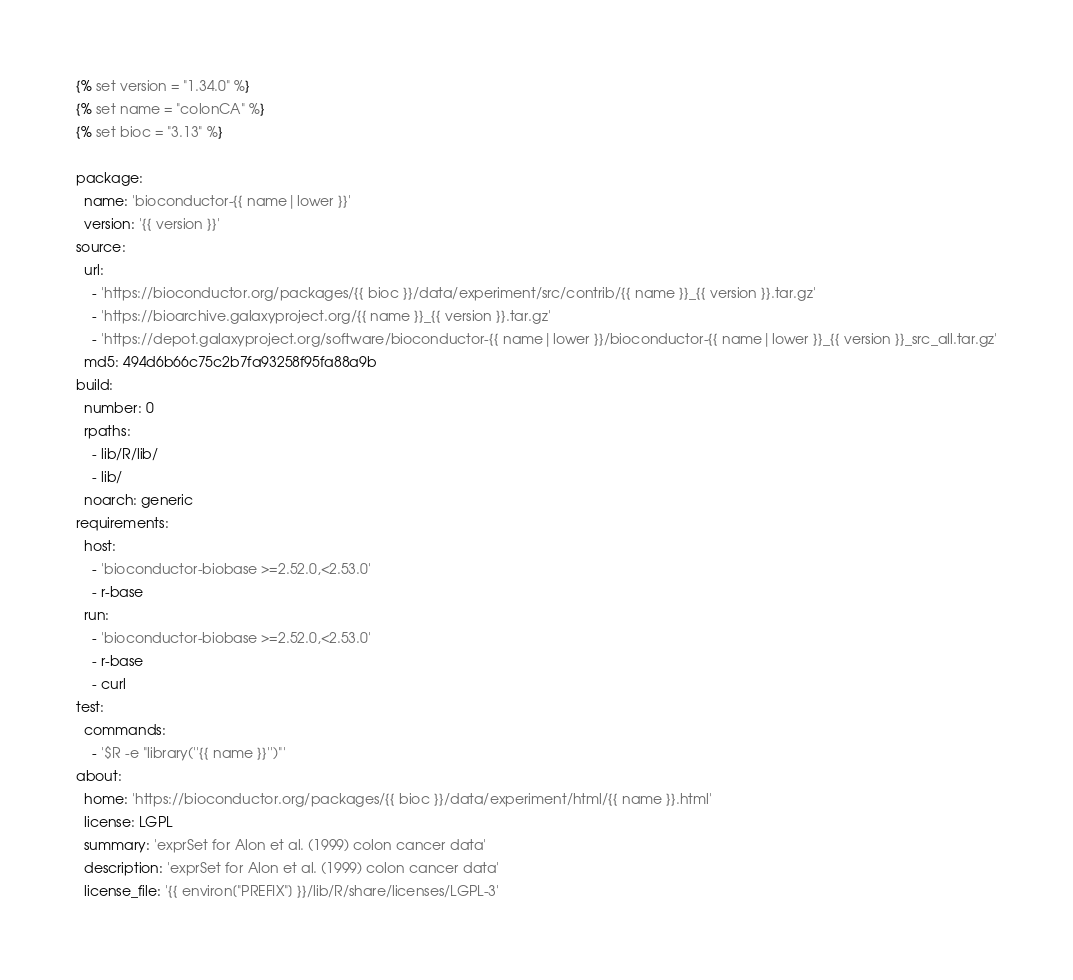Convert code to text. <code><loc_0><loc_0><loc_500><loc_500><_YAML_>{% set version = "1.34.0" %}
{% set name = "colonCA" %}
{% set bioc = "3.13" %}

package:
  name: 'bioconductor-{{ name|lower }}'
  version: '{{ version }}'
source:
  url:
    - 'https://bioconductor.org/packages/{{ bioc }}/data/experiment/src/contrib/{{ name }}_{{ version }}.tar.gz'
    - 'https://bioarchive.galaxyproject.org/{{ name }}_{{ version }}.tar.gz'
    - 'https://depot.galaxyproject.org/software/bioconductor-{{ name|lower }}/bioconductor-{{ name|lower }}_{{ version }}_src_all.tar.gz'
  md5: 494d6b66c75c2b7fa93258f95fa88a9b
build:
  number: 0
  rpaths:
    - lib/R/lib/
    - lib/
  noarch: generic
requirements:
  host:
    - 'bioconductor-biobase >=2.52.0,<2.53.0'
    - r-base
  run:
    - 'bioconductor-biobase >=2.52.0,<2.53.0'
    - r-base
    - curl
test:
  commands:
    - '$R -e "library(''{{ name }}'')"'
about:
  home: 'https://bioconductor.org/packages/{{ bioc }}/data/experiment/html/{{ name }}.html'
  license: LGPL
  summary: 'exprSet for Alon et al. (1999) colon cancer data'
  description: 'exprSet for Alon et al. (1999) colon cancer data'
  license_file: '{{ environ["PREFIX"] }}/lib/R/share/licenses/LGPL-3'

</code> 